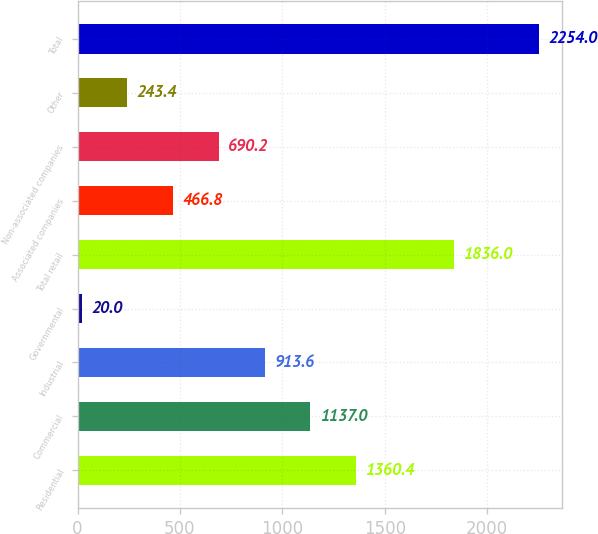Convert chart to OTSL. <chart><loc_0><loc_0><loc_500><loc_500><bar_chart><fcel>Residential<fcel>Commercial<fcel>Industrial<fcel>Governmental<fcel>Total retail<fcel>Associated companies<fcel>Non-associated companies<fcel>Other<fcel>Total<nl><fcel>1360.4<fcel>1137<fcel>913.6<fcel>20<fcel>1836<fcel>466.8<fcel>690.2<fcel>243.4<fcel>2254<nl></chart> 